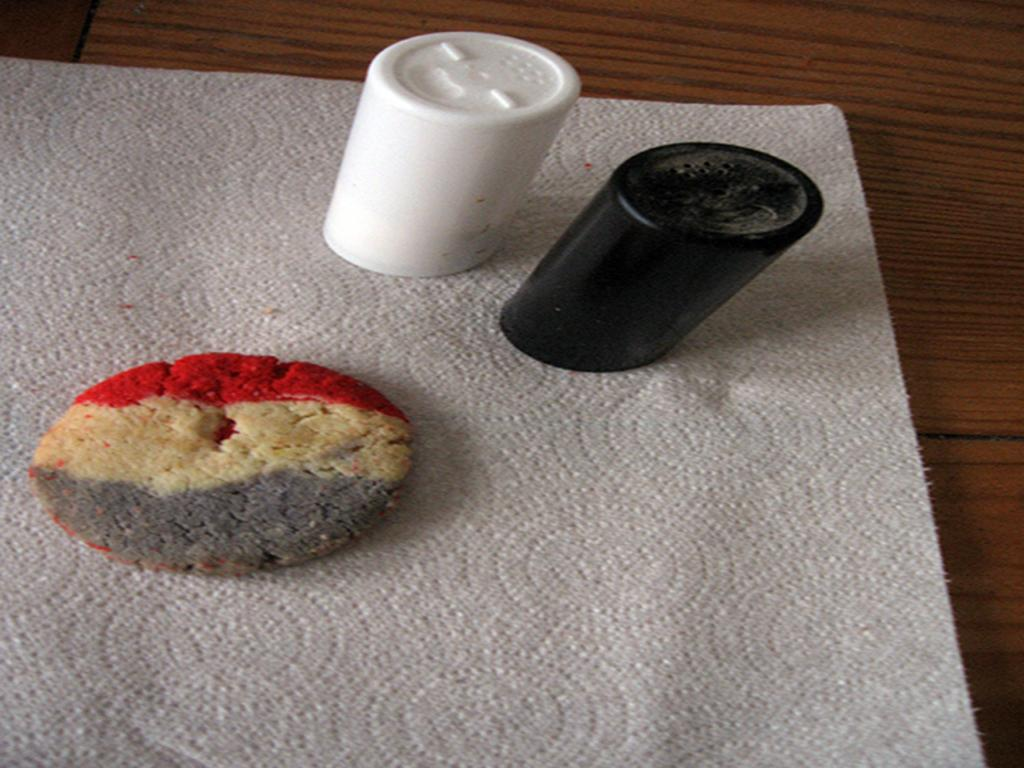What piece of furniture is present in the image? There is a table in the image. What is covering the table? There is a cloth on the table. What type of food item can be seen on the cloth? There is a cookie on the cloth. What type of dishware is present on the cloth? There are glasses on the cloth. How many pieces of produce are visible on the table? There is no produce visible on the table in the image. What type of thread is used to sew the cloth on the table? The cloth on the table does not show any visible stitching or thread, and the type of thread used is not mentioned in the facts provided. 